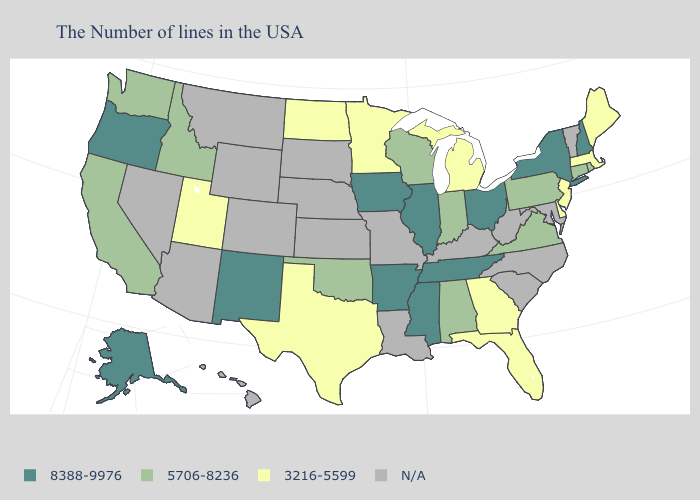What is the value of Texas?
Keep it brief. 3216-5599. Which states have the highest value in the USA?
Answer briefly. New Hampshire, New York, Ohio, Tennessee, Illinois, Mississippi, Arkansas, Iowa, New Mexico, Oregon, Alaska. Name the states that have a value in the range N/A?
Answer briefly. Vermont, Maryland, North Carolina, South Carolina, West Virginia, Kentucky, Louisiana, Missouri, Kansas, Nebraska, South Dakota, Wyoming, Colorado, Montana, Arizona, Nevada, Hawaii. Is the legend a continuous bar?
Write a very short answer. No. What is the value of Louisiana?
Answer briefly. N/A. Does the map have missing data?
Keep it brief. Yes. How many symbols are there in the legend?
Keep it brief. 4. Does the first symbol in the legend represent the smallest category?
Write a very short answer. No. Does Michigan have the highest value in the USA?
Answer briefly. No. What is the value of Maryland?
Concise answer only. N/A. Which states have the highest value in the USA?
Short answer required. New Hampshire, New York, Ohio, Tennessee, Illinois, Mississippi, Arkansas, Iowa, New Mexico, Oregon, Alaska. Which states have the highest value in the USA?
Quick response, please. New Hampshire, New York, Ohio, Tennessee, Illinois, Mississippi, Arkansas, Iowa, New Mexico, Oregon, Alaska. What is the value of Idaho?
Give a very brief answer. 5706-8236. 